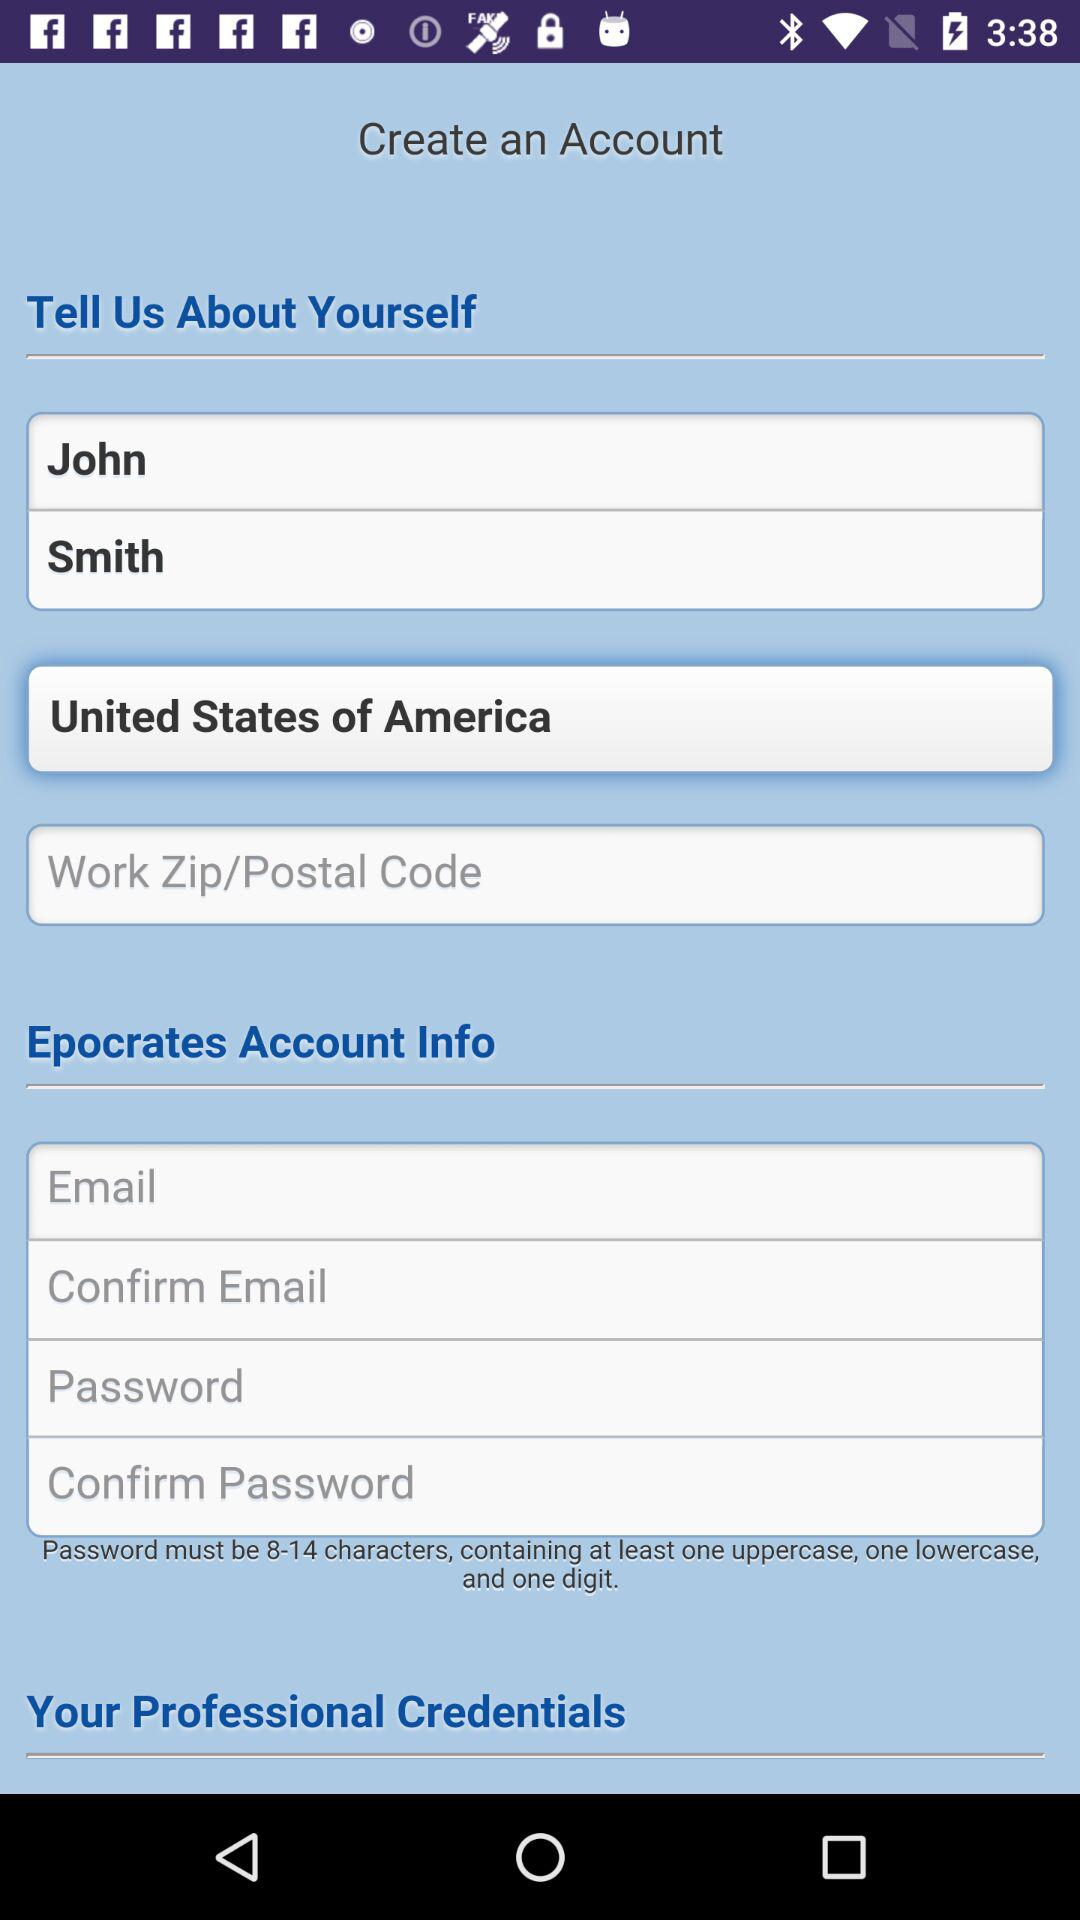Where is the user located? The user is located in the United States of America. 